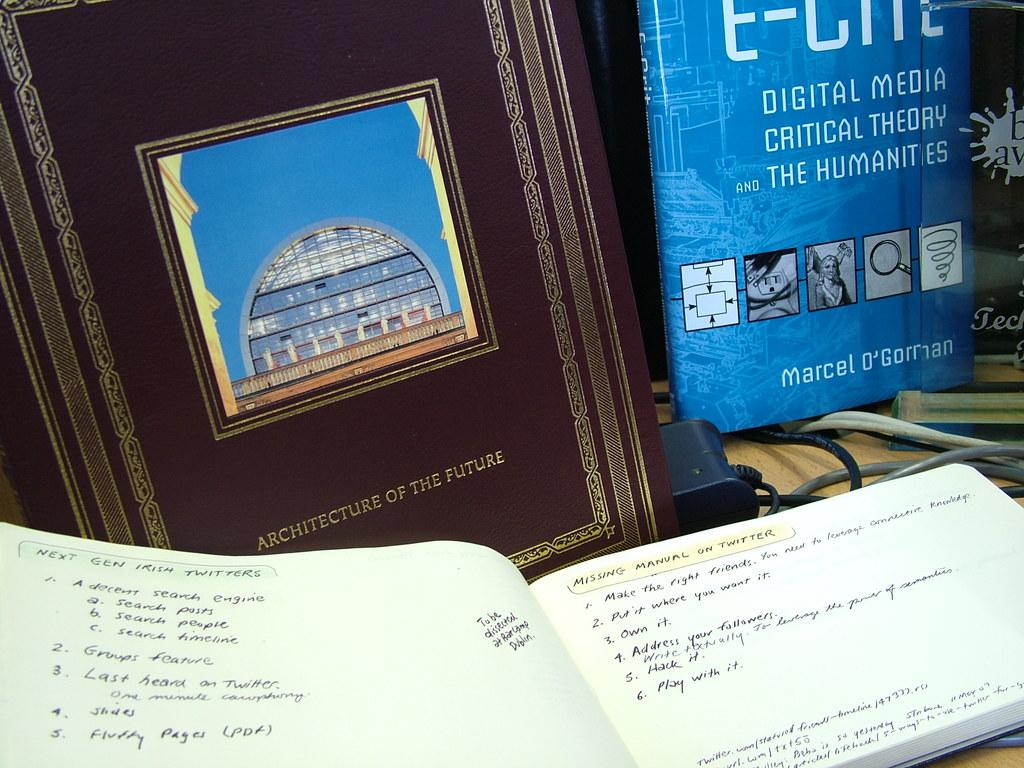Provide a one-sentence caption for the provided image. A book is propped up next to a frame that is authored by someone named Marcel. 